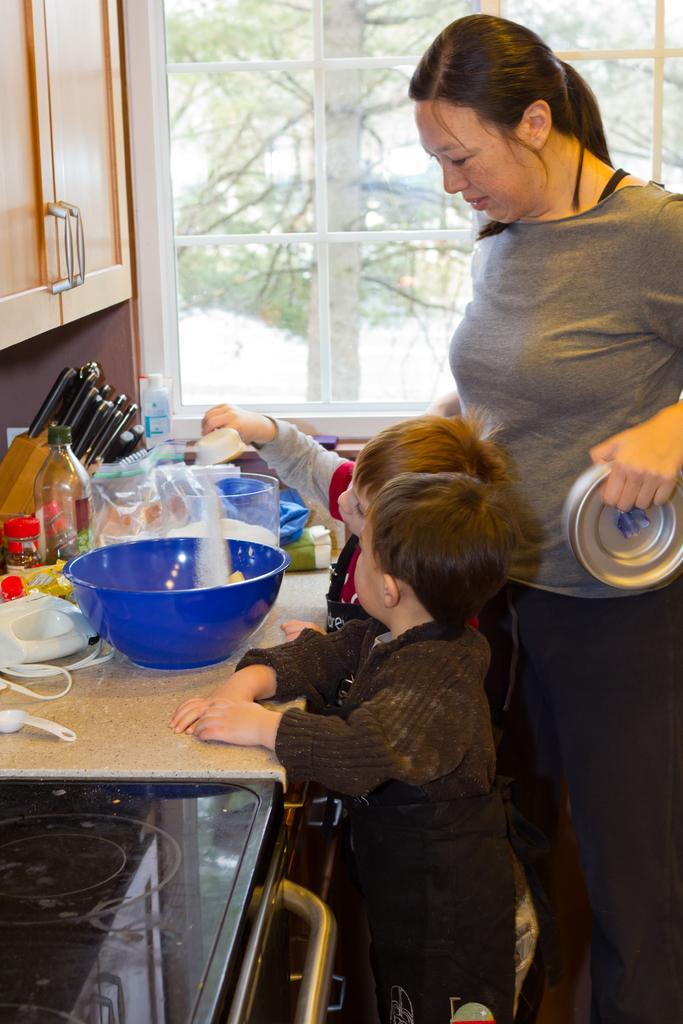Can you describe this image briefly? In this image, there are three persons standing. Among them two persons holding the objects. In front of three persons, there is a bowl, spoon, bottle, jars, a knife set and few other objects on a kitchen cabin and I can see a cupboard. In the bottom left corner of the image, I can see an induction stove. In the background, I can see the trees through a glass window. 